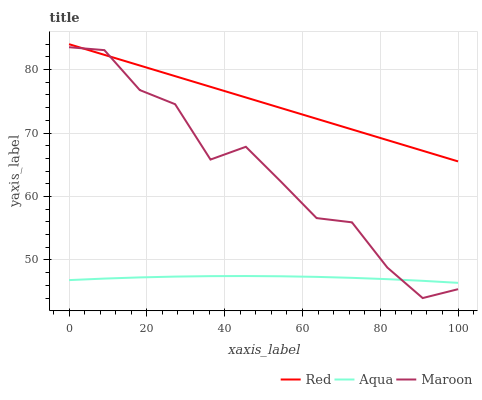Does Aqua have the minimum area under the curve?
Answer yes or no. Yes. Does Red have the maximum area under the curve?
Answer yes or no. Yes. Does Maroon have the minimum area under the curve?
Answer yes or no. No. Does Maroon have the maximum area under the curve?
Answer yes or no. No. Is Red the smoothest?
Answer yes or no. Yes. Is Maroon the roughest?
Answer yes or no. Yes. Is Maroon the smoothest?
Answer yes or no. No. Is Red the roughest?
Answer yes or no. No. Does Red have the lowest value?
Answer yes or no. No. Does Maroon have the highest value?
Answer yes or no. No. Is Aqua less than Red?
Answer yes or no. Yes. Is Red greater than Aqua?
Answer yes or no. Yes. Does Aqua intersect Red?
Answer yes or no. No. 